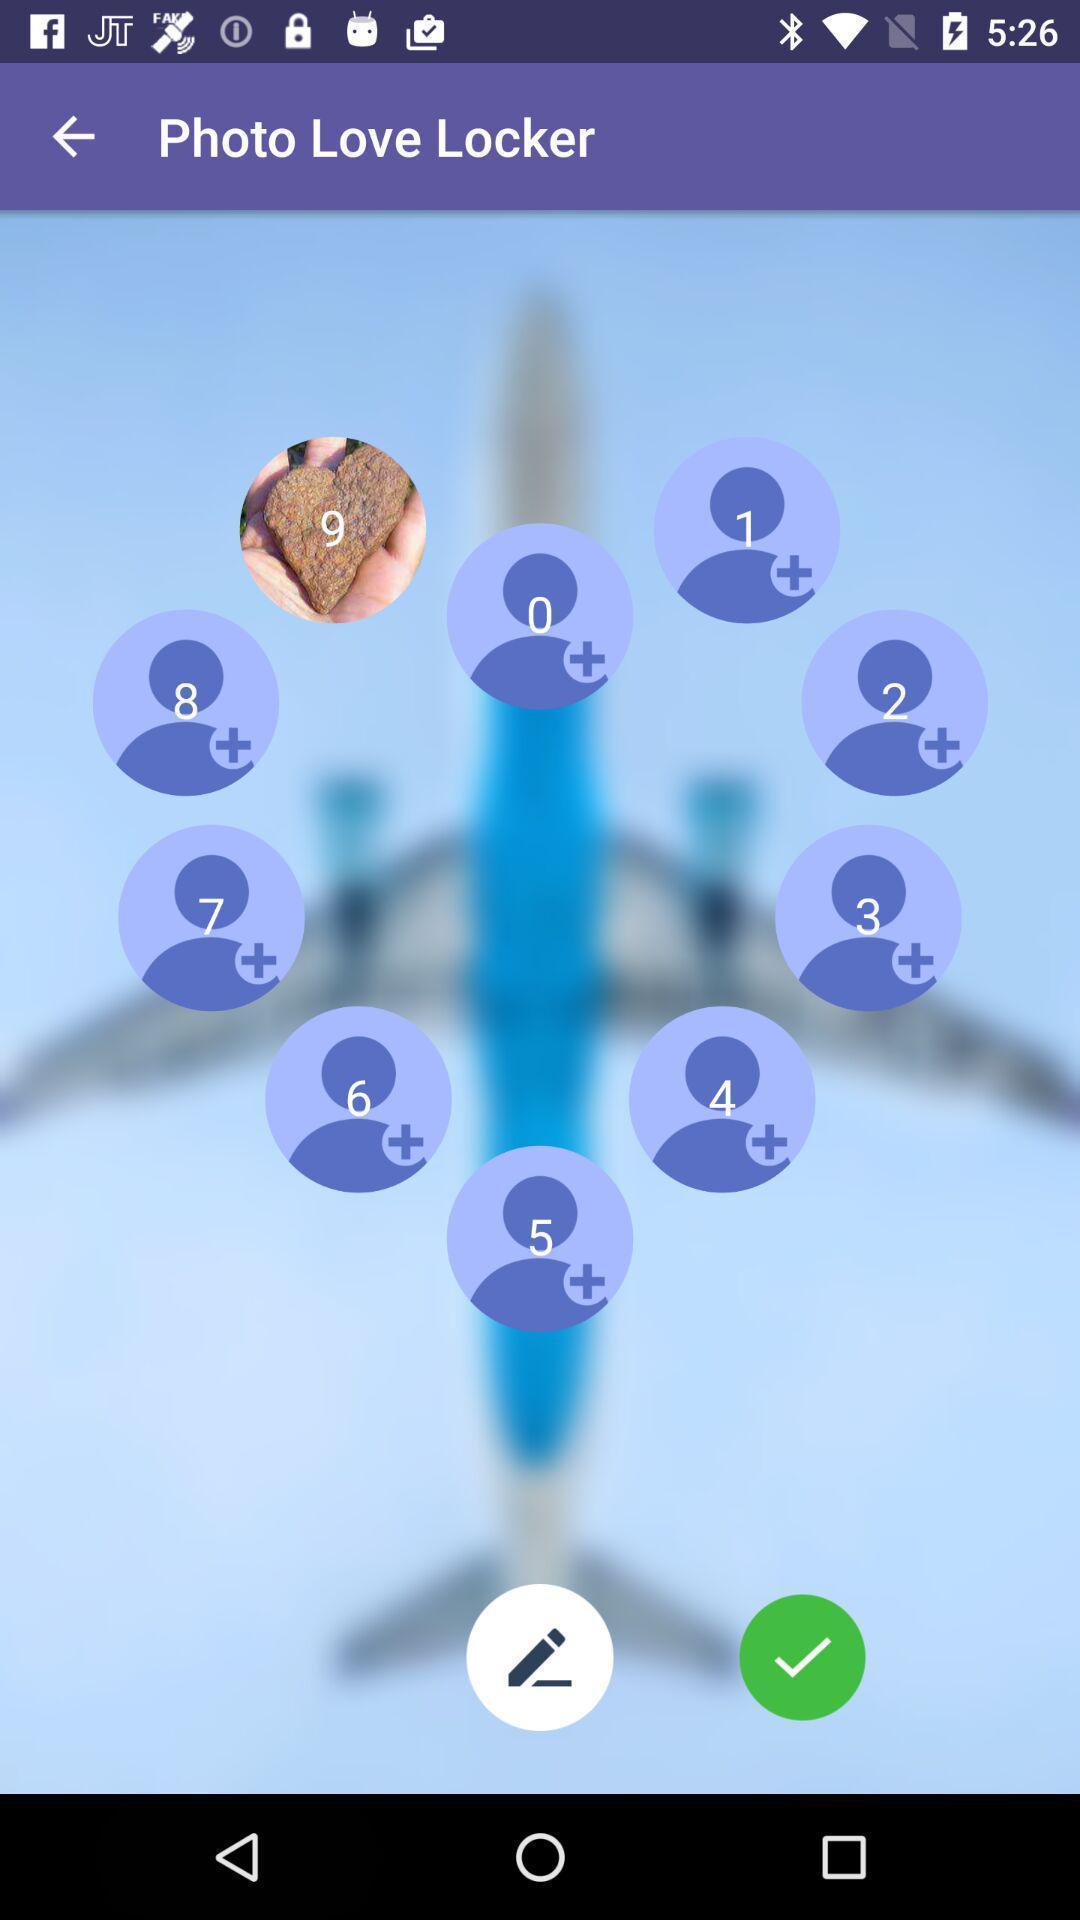What is the overall content of this screenshot? Welcome page with several icons. 